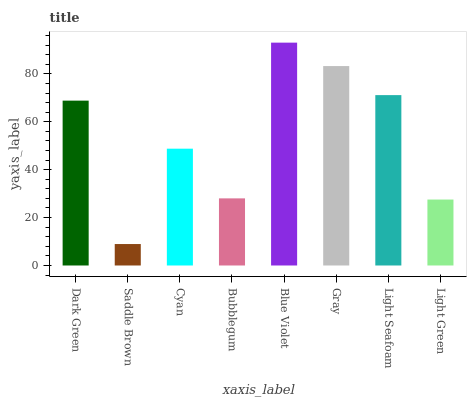Is Saddle Brown the minimum?
Answer yes or no. Yes. Is Blue Violet the maximum?
Answer yes or no. Yes. Is Cyan the minimum?
Answer yes or no. No. Is Cyan the maximum?
Answer yes or no. No. Is Cyan greater than Saddle Brown?
Answer yes or no. Yes. Is Saddle Brown less than Cyan?
Answer yes or no. Yes. Is Saddle Brown greater than Cyan?
Answer yes or no. No. Is Cyan less than Saddle Brown?
Answer yes or no. No. Is Dark Green the high median?
Answer yes or no. Yes. Is Cyan the low median?
Answer yes or no. Yes. Is Saddle Brown the high median?
Answer yes or no. No. Is Light Seafoam the low median?
Answer yes or no. No. 